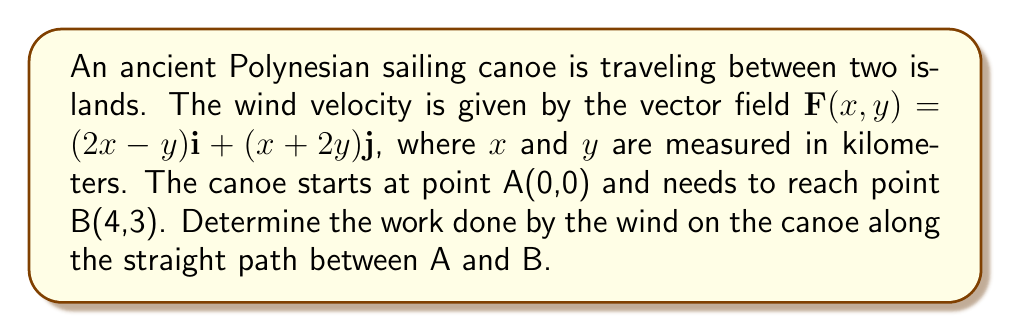Could you help me with this problem? To solve this problem, we'll use line integrals from vector calculus:

1) The straight path from A to B can be parameterized as:
   $x(t) = 4t$, $y(t) = 3t$, where $0 \leq t \leq 1$

2) The vector $\mathbf{r}(t) = (4t)\mathbf{i} + (3t)\mathbf{j}$ represents this path.

3) We need to calculate $\int_C \mathbf{F} \cdot d\mathbf{r}$, where C is the path from A to B.

4) $d\mathbf{r} = (4dt)\mathbf{i} + (3dt)\mathbf{j}$

5) Along the path:
   $\mathbf{F}(x(t),y(t)) = (2(4t)-3t)\mathbf{i} + (4t+2(3t))\mathbf{j}$
                          $= (8t-3t)\mathbf{i} + (4t+6t)\mathbf{j}$
                          $= (5t)\mathbf{i} + (10t)\mathbf{j}$

6) Now, we calculate the dot product:
   $\mathbf{F} \cdot d\mathbf{r} = (5t)(4dt) + (10t)(3dt) = 20t dt + 30t dt = 50t dt$

7) The work is the integral of this dot product:
   $W = \int_0^1 50t dt = 50 \cdot \frac{1}{2}t^2 |_0^1 = 25$ kilometer-newtons

Therefore, the work done by the wind on the canoe is 25 kilometer-newtons.
Answer: 25 kilometer-newtons 